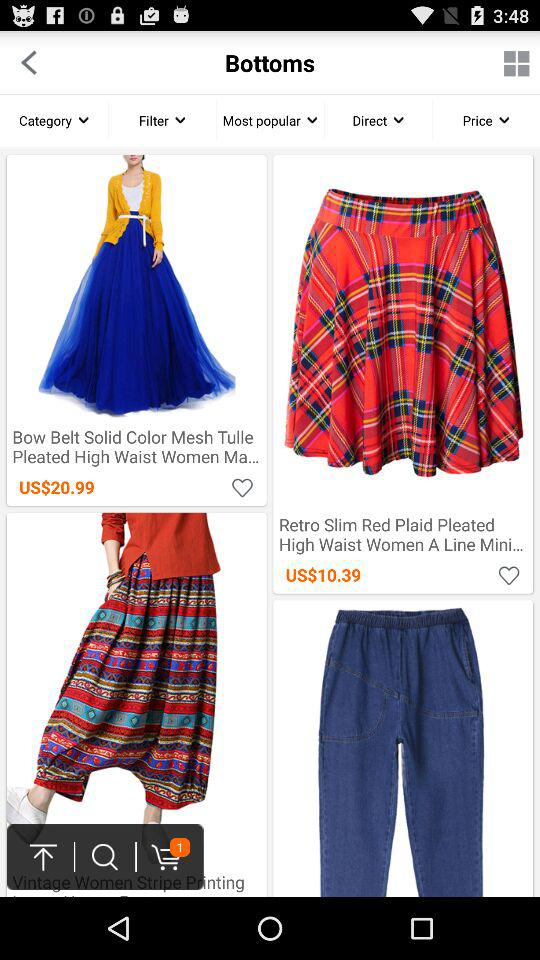What is the price of the "Retro Slim Red Plaid Pleated"? The price of the "Retro Slim Red Plaid Pleated" is US$10.39. 